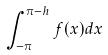Convert formula to latex. <formula><loc_0><loc_0><loc_500><loc_500>\int _ { - \pi } ^ { \pi - h } f ( x ) d x</formula> 